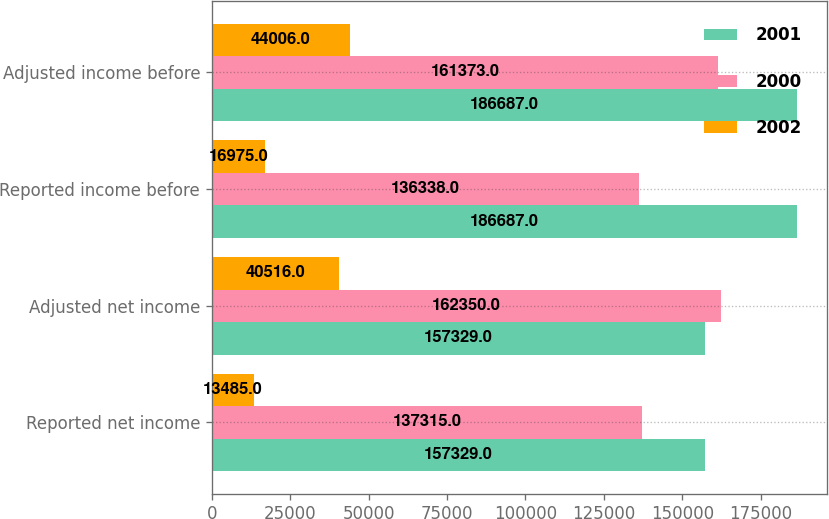<chart> <loc_0><loc_0><loc_500><loc_500><stacked_bar_chart><ecel><fcel>Reported net income<fcel>Adjusted net income<fcel>Reported income before<fcel>Adjusted income before<nl><fcel>2001<fcel>157329<fcel>157329<fcel>186687<fcel>186687<nl><fcel>2000<fcel>137315<fcel>162350<fcel>136338<fcel>161373<nl><fcel>2002<fcel>13485<fcel>40516<fcel>16975<fcel>44006<nl></chart> 